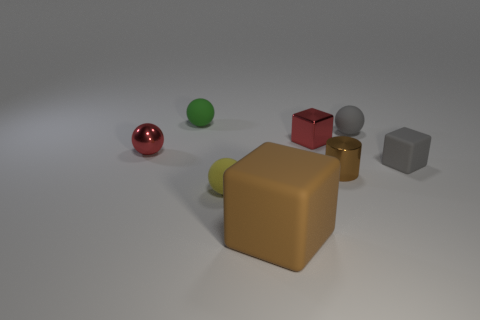Are there any other things that have the same size as the brown rubber object?
Make the answer very short. No. How many objects are tiny metal cubes or large cyan things?
Your response must be concise. 1. Are there any blocks that have the same material as the small brown cylinder?
Your answer should be compact. Yes. What size is the cube that is the same color as the cylinder?
Give a very brief answer. Large. There is a small cube on the left side of the rubber cube behind the large rubber block; what color is it?
Ensure brevity in your answer.  Red. Is the brown shiny cylinder the same size as the gray block?
Keep it short and to the point. Yes. What number of cubes are either brown objects or tiny rubber things?
Your answer should be very brief. 2. There is a small block left of the gray rubber ball; what number of tiny green rubber balls are in front of it?
Ensure brevity in your answer.  0. Do the small green matte object and the yellow object have the same shape?
Your response must be concise. Yes. What is the size of the gray thing that is the same shape as the green object?
Offer a very short reply. Small. 